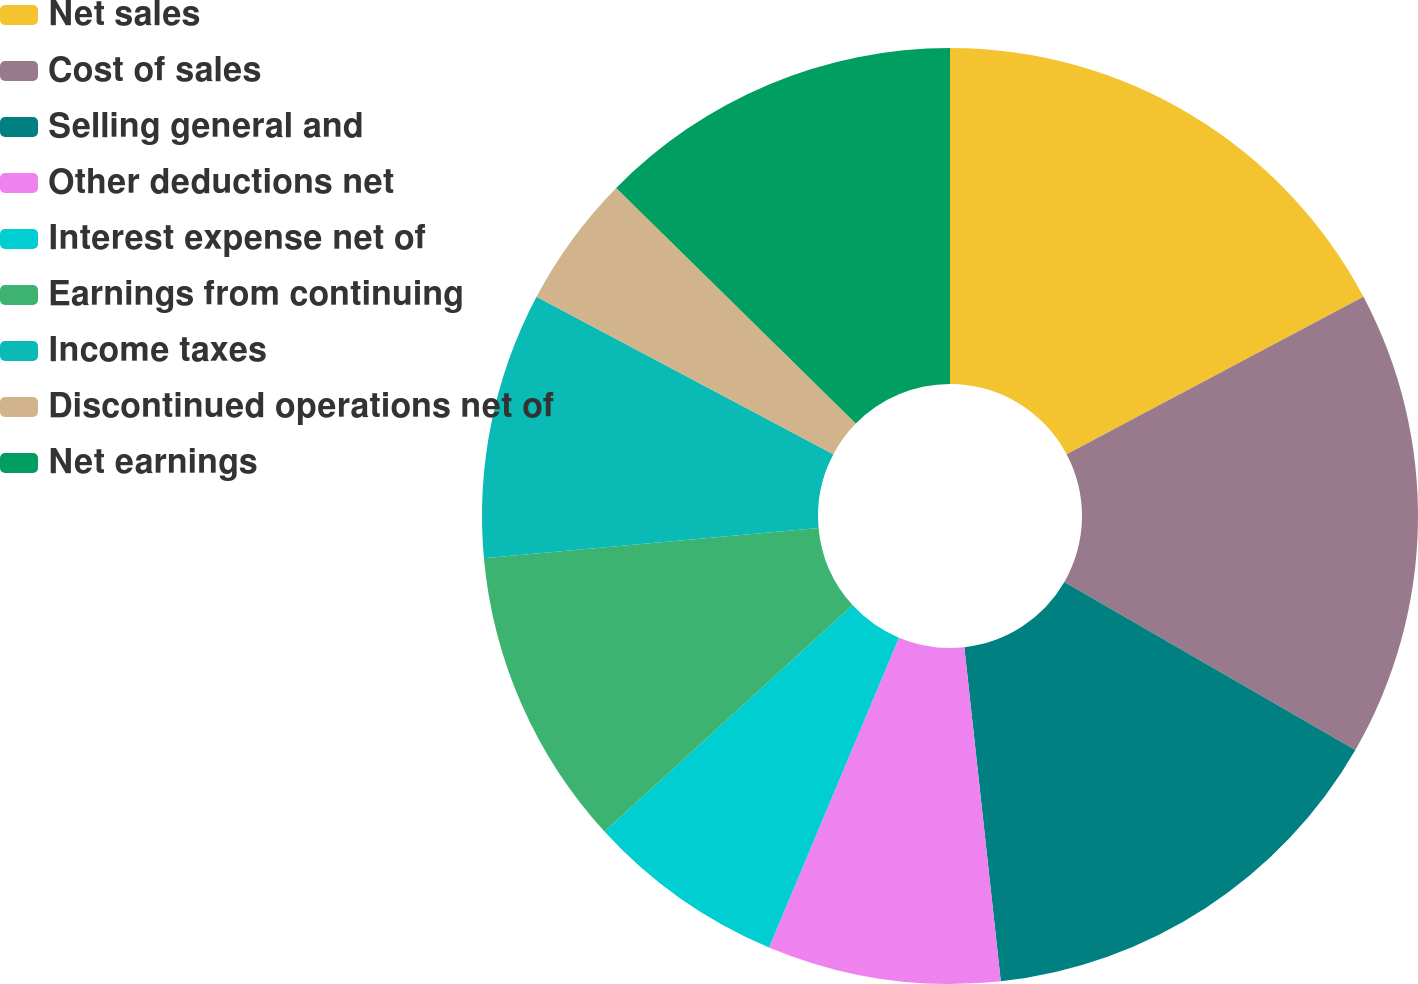Convert chart. <chart><loc_0><loc_0><loc_500><loc_500><pie_chart><fcel>Net sales<fcel>Cost of sales<fcel>Selling general and<fcel>Other deductions net<fcel>Interest expense net of<fcel>Earnings from continuing<fcel>Income taxes<fcel>Discontinued operations net of<fcel>Net earnings<nl><fcel>17.24%<fcel>16.09%<fcel>14.94%<fcel>8.05%<fcel>6.9%<fcel>10.34%<fcel>9.2%<fcel>4.6%<fcel>12.64%<nl></chart> 